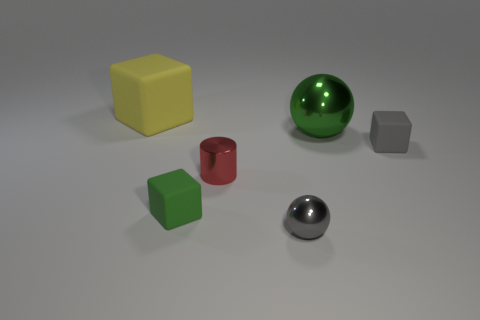There is a big object that is on the right side of the tiny red shiny cylinder; how many gray balls are in front of it?
Give a very brief answer. 1. Is there anything else of the same color as the small shiny ball?
Give a very brief answer. Yes. How many things are either gray metallic things or metal things left of the large ball?
Offer a very short reply. 2. There is a tiny gray object to the left of the big object that is on the right side of the tiny cube left of the large shiny thing; what is its material?
Keep it short and to the point. Metal. What size is the gray sphere that is made of the same material as the small red thing?
Your response must be concise. Small. There is a thing to the right of the large object that is in front of the big yellow thing; what color is it?
Your response must be concise. Gray. What number of objects are made of the same material as the small gray sphere?
Offer a very short reply. 2. What number of rubber objects are small gray cubes or cylinders?
Your response must be concise. 1. There is a green thing that is the same size as the red metallic object; what is its material?
Ensure brevity in your answer.  Rubber. Is there a small red ball that has the same material as the tiny gray ball?
Ensure brevity in your answer.  No. 